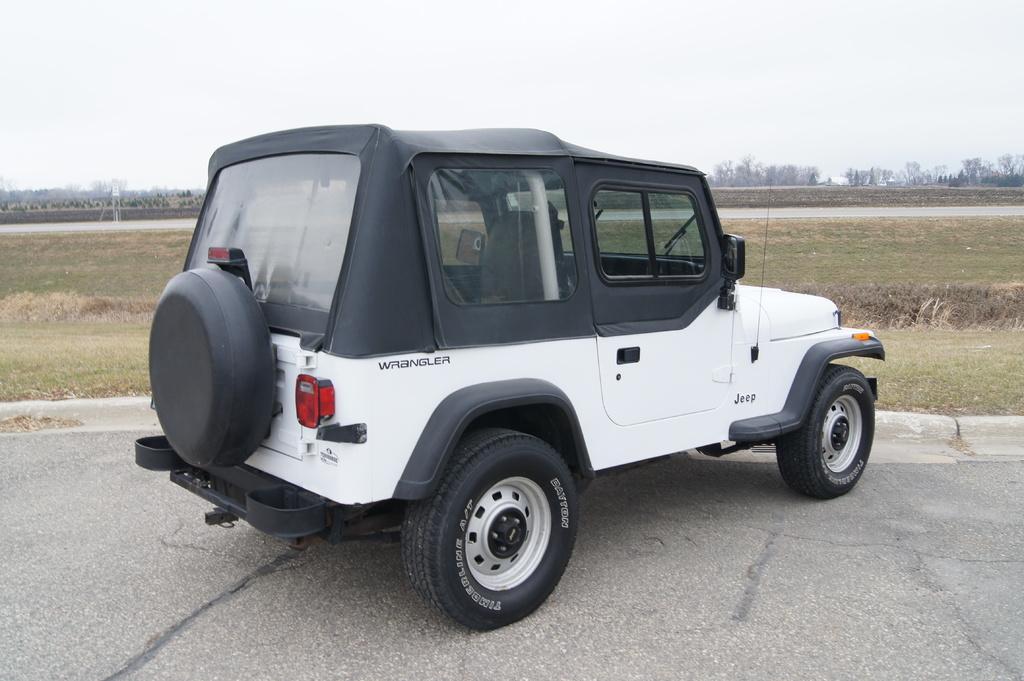In one or two sentences, can you explain what this image depicts? In the middle of the image we can see a vehicle on the road, in the background we can see grass and few trees. 